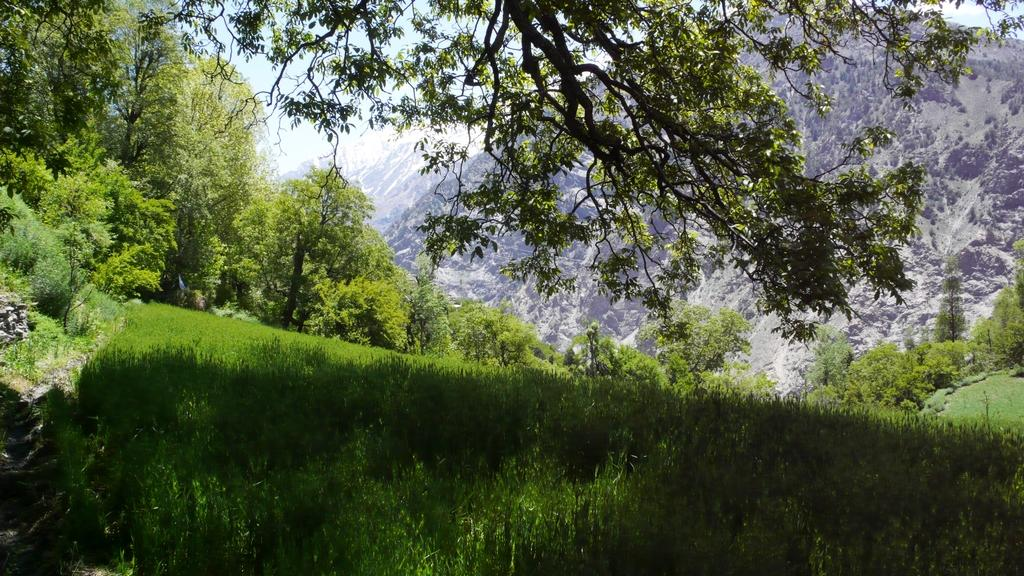What type of vegetation can be seen in the image? There are trees and plants in the image. What is covering the ground in the image? There is grass on the ground in the image. What can be seen in the distance in the image? There are mountains visible in the background of the image. What type of company is operating the horse-drawn system in the image? There are no horses or any system involving them in the image. 